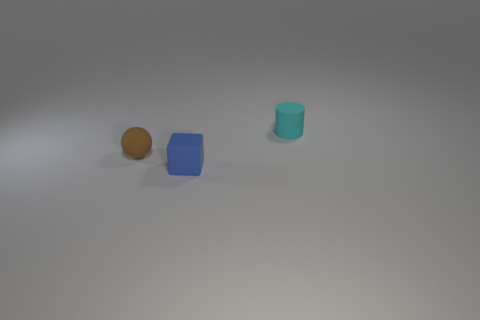Add 1 purple shiny spheres. How many objects exist? 4 Subtract all cylinders. How many objects are left? 2 Subtract 1 blocks. How many blocks are left? 0 Subtract all cyan spheres. Subtract all brown cylinders. How many spheres are left? 1 Subtract all green cubes. How many blue balls are left? 0 Subtract all blue rubber cylinders. Subtract all blue matte objects. How many objects are left? 2 Add 3 blue rubber things. How many blue rubber things are left? 4 Add 3 small matte blocks. How many small matte blocks exist? 4 Subtract 0 brown cylinders. How many objects are left? 3 